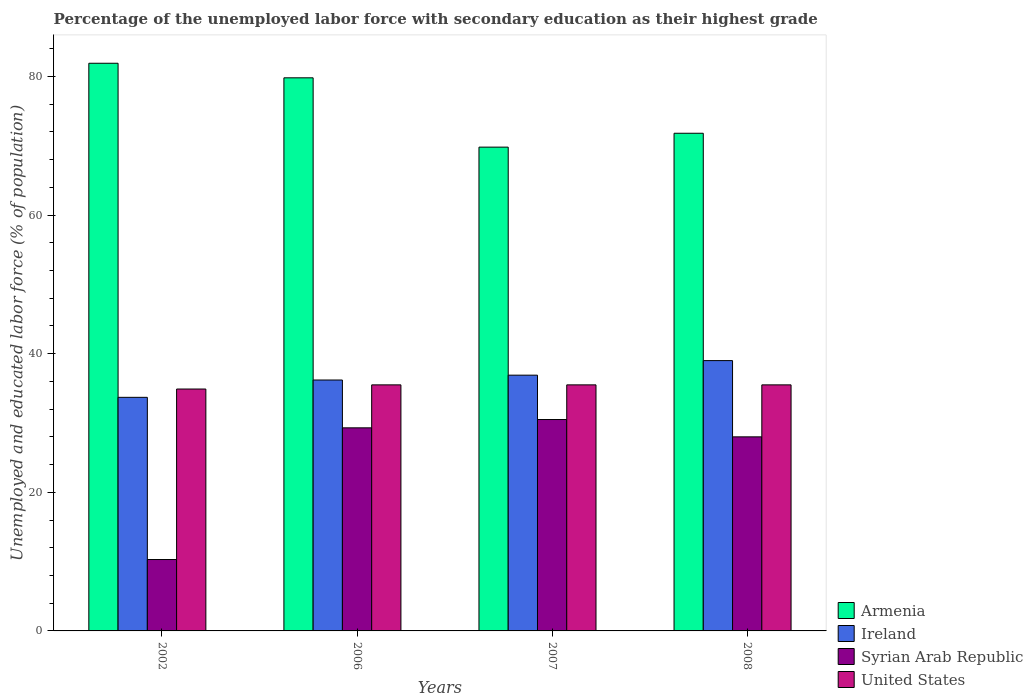How many different coloured bars are there?
Your answer should be very brief. 4. Are the number of bars per tick equal to the number of legend labels?
Keep it short and to the point. Yes. Are the number of bars on each tick of the X-axis equal?
Provide a short and direct response. Yes. How many bars are there on the 4th tick from the left?
Give a very brief answer. 4. How many bars are there on the 1st tick from the right?
Ensure brevity in your answer.  4. What is the label of the 2nd group of bars from the left?
Make the answer very short. 2006. What is the percentage of the unemployed labor force with secondary education in Armenia in 2002?
Your answer should be compact. 81.9. Across all years, what is the maximum percentage of the unemployed labor force with secondary education in Syrian Arab Republic?
Provide a succinct answer. 30.5. Across all years, what is the minimum percentage of the unemployed labor force with secondary education in Syrian Arab Republic?
Your response must be concise. 10.3. In which year was the percentage of the unemployed labor force with secondary education in Ireland maximum?
Offer a terse response. 2008. In which year was the percentage of the unemployed labor force with secondary education in Armenia minimum?
Give a very brief answer. 2007. What is the total percentage of the unemployed labor force with secondary education in Armenia in the graph?
Provide a short and direct response. 303.3. What is the difference between the percentage of the unemployed labor force with secondary education in Ireland in 2006 and that in 2007?
Offer a very short reply. -0.7. What is the difference between the percentage of the unemployed labor force with secondary education in United States in 2008 and the percentage of the unemployed labor force with secondary education in Ireland in 2007?
Keep it short and to the point. -1.4. What is the average percentage of the unemployed labor force with secondary education in Ireland per year?
Your answer should be very brief. 36.45. In the year 2006, what is the difference between the percentage of the unemployed labor force with secondary education in Armenia and percentage of the unemployed labor force with secondary education in United States?
Your answer should be very brief. 44.3. What is the ratio of the percentage of the unemployed labor force with secondary education in United States in 2002 to that in 2006?
Make the answer very short. 0.98. What is the difference between the highest and the second highest percentage of the unemployed labor force with secondary education in Syrian Arab Republic?
Make the answer very short. 1.2. What is the difference between the highest and the lowest percentage of the unemployed labor force with secondary education in Syrian Arab Republic?
Ensure brevity in your answer.  20.2. In how many years, is the percentage of the unemployed labor force with secondary education in Ireland greater than the average percentage of the unemployed labor force with secondary education in Ireland taken over all years?
Your answer should be very brief. 2. Is it the case that in every year, the sum of the percentage of the unemployed labor force with secondary education in Armenia and percentage of the unemployed labor force with secondary education in Syrian Arab Republic is greater than the sum of percentage of the unemployed labor force with secondary education in United States and percentage of the unemployed labor force with secondary education in Ireland?
Ensure brevity in your answer.  Yes. What does the 3rd bar from the left in 2007 represents?
Provide a short and direct response. Syrian Arab Republic. What does the 3rd bar from the right in 2002 represents?
Offer a very short reply. Ireland. Are all the bars in the graph horizontal?
Ensure brevity in your answer.  No. How many years are there in the graph?
Your answer should be compact. 4. What is the difference between two consecutive major ticks on the Y-axis?
Make the answer very short. 20. Are the values on the major ticks of Y-axis written in scientific E-notation?
Your answer should be very brief. No. Does the graph contain grids?
Offer a very short reply. No. Where does the legend appear in the graph?
Make the answer very short. Bottom right. What is the title of the graph?
Offer a terse response. Percentage of the unemployed labor force with secondary education as their highest grade. What is the label or title of the Y-axis?
Ensure brevity in your answer.  Unemployed and educated labor force (% of population). What is the Unemployed and educated labor force (% of population) in Armenia in 2002?
Provide a succinct answer. 81.9. What is the Unemployed and educated labor force (% of population) of Ireland in 2002?
Your answer should be very brief. 33.7. What is the Unemployed and educated labor force (% of population) of Syrian Arab Republic in 2002?
Provide a short and direct response. 10.3. What is the Unemployed and educated labor force (% of population) in United States in 2002?
Provide a succinct answer. 34.9. What is the Unemployed and educated labor force (% of population) of Armenia in 2006?
Your answer should be compact. 79.8. What is the Unemployed and educated labor force (% of population) of Ireland in 2006?
Provide a short and direct response. 36.2. What is the Unemployed and educated labor force (% of population) in Syrian Arab Republic in 2006?
Ensure brevity in your answer.  29.3. What is the Unemployed and educated labor force (% of population) of United States in 2006?
Ensure brevity in your answer.  35.5. What is the Unemployed and educated labor force (% of population) in Armenia in 2007?
Provide a succinct answer. 69.8. What is the Unemployed and educated labor force (% of population) of Ireland in 2007?
Offer a terse response. 36.9. What is the Unemployed and educated labor force (% of population) of Syrian Arab Republic in 2007?
Provide a short and direct response. 30.5. What is the Unemployed and educated labor force (% of population) of United States in 2007?
Make the answer very short. 35.5. What is the Unemployed and educated labor force (% of population) of Armenia in 2008?
Your response must be concise. 71.8. What is the Unemployed and educated labor force (% of population) of United States in 2008?
Ensure brevity in your answer.  35.5. Across all years, what is the maximum Unemployed and educated labor force (% of population) of Armenia?
Give a very brief answer. 81.9. Across all years, what is the maximum Unemployed and educated labor force (% of population) in Syrian Arab Republic?
Your answer should be very brief. 30.5. Across all years, what is the maximum Unemployed and educated labor force (% of population) of United States?
Provide a short and direct response. 35.5. Across all years, what is the minimum Unemployed and educated labor force (% of population) in Armenia?
Offer a very short reply. 69.8. Across all years, what is the minimum Unemployed and educated labor force (% of population) of Ireland?
Provide a succinct answer. 33.7. Across all years, what is the minimum Unemployed and educated labor force (% of population) in Syrian Arab Republic?
Your answer should be very brief. 10.3. Across all years, what is the minimum Unemployed and educated labor force (% of population) of United States?
Offer a very short reply. 34.9. What is the total Unemployed and educated labor force (% of population) of Armenia in the graph?
Offer a very short reply. 303.3. What is the total Unemployed and educated labor force (% of population) in Ireland in the graph?
Keep it short and to the point. 145.8. What is the total Unemployed and educated labor force (% of population) in Syrian Arab Republic in the graph?
Make the answer very short. 98.1. What is the total Unemployed and educated labor force (% of population) of United States in the graph?
Provide a succinct answer. 141.4. What is the difference between the Unemployed and educated labor force (% of population) of Syrian Arab Republic in 2002 and that in 2006?
Provide a succinct answer. -19. What is the difference between the Unemployed and educated labor force (% of population) in Ireland in 2002 and that in 2007?
Give a very brief answer. -3.2. What is the difference between the Unemployed and educated labor force (% of population) of Syrian Arab Republic in 2002 and that in 2007?
Your answer should be very brief. -20.2. What is the difference between the Unemployed and educated labor force (% of population) of United States in 2002 and that in 2007?
Offer a terse response. -0.6. What is the difference between the Unemployed and educated labor force (% of population) in Ireland in 2002 and that in 2008?
Provide a succinct answer. -5.3. What is the difference between the Unemployed and educated labor force (% of population) of Syrian Arab Republic in 2002 and that in 2008?
Your answer should be very brief. -17.7. What is the difference between the Unemployed and educated labor force (% of population) in United States in 2002 and that in 2008?
Make the answer very short. -0.6. What is the difference between the Unemployed and educated labor force (% of population) of United States in 2006 and that in 2007?
Make the answer very short. 0. What is the difference between the Unemployed and educated labor force (% of population) in Armenia in 2006 and that in 2008?
Provide a short and direct response. 8. What is the difference between the Unemployed and educated labor force (% of population) of Syrian Arab Republic in 2006 and that in 2008?
Your response must be concise. 1.3. What is the difference between the Unemployed and educated labor force (% of population) of United States in 2006 and that in 2008?
Give a very brief answer. 0. What is the difference between the Unemployed and educated labor force (% of population) in Ireland in 2007 and that in 2008?
Your answer should be very brief. -2.1. What is the difference between the Unemployed and educated labor force (% of population) of Syrian Arab Republic in 2007 and that in 2008?
Your answer should be compact. 2.5. What is the difference between the Unemployed and educated labor force (% of population) in United States in 2007 and that in 2008?
Make the answer very short. 0. What is the difference between the Unemployed and educated labor force (% of population) of Armenia in 2002 and the Unemployed and educated labor force (% of population) of Ireland in 2006?
Your answer should be very brief. 45.7. What is the difference between the Unemployed and educated labor force (% of population) of Armenia in 2002 and the Unemployed and educated labor force (% of population) of Syrian Arab Republic in 2006?
Your response must be concise. 52.6. What is the difference between the Unemployed and educated labor force (% of population) of Armenia in 2002 and the Unemployed and educated labor force (% of population) of United States in 2006?
Provide a short and direct response. 46.4. What is the difference between the Unemployed and educated labor force (% of population) of Ireland in 2002 and the Unemployed and educated labor force (% of population) of Syrian Arab Republic in 2006?
Give a very brief answer. 4.4. What is the difference between the Unemployed and educated labor force (% of population) in Syrian Arab Republic in 2002 and the Unemployed and educated labor force (% of population) in United States in 2006?
Your answer should be compact. -25.2. What is the difference between the Unemployed and educated labor force (% of population) in Armenia in 2002 and the Unemployed and educated labor force (% of population) in Ireland in 2007?
Offer a terse response. 45. What is the difference between the Unemployed and educated labor force (% of population) in Armenia in 2002 and the Unemployed and educated labor force (% of population) in Syrian Arab Republic in 2007?
Provide a short and direct response. 51.4. What is the difference between the Unemployed and educated labor force (% of population) in Armenia in 2002 and the Unemployed and educated labor force (% of population) in United States in 2007?
Keep it short and to the point. 46.4. What is the difference between the Unemployed and educated labor force (% of population) of Ireland in 2002 and the Unemployed and educated labor force (% of population) of United States in 2007?
Offer a very short reply. -1.8. What is the difference between the Unemployed and educated labor force (% of population) in Syrian Arab Republic in 2002 and the Unemployed and educated labor force (% of population) in United States in 2007?
Offer a terse response. -25.2. What is the difference between the Unemployed and educated labor force (% of population) in Armenia in 2002 and the Unemployed and educated labor force (% of population) in Ireland in 2008?
Give a very brief answer. 42.9. What is the difference between the Unemployed and educated labor force (% of population) of Armenia in 2002 and the Unemployed and educated labor force (% of population) of Syrian Arab Republic in 2008?
Your response must be concise. 53.9. What is the difference between the Unemployed and educated labor force (% of population) of Armenia in 2002 and the Unemployed and educated labor force (% of population) of United States in 2008?
Your answer should be very brief. 46.4. What is the difference between the Unemployed and educated labor force (% of population) of Ireland in 2002 and the Unemployed and educated labor force (% of population) of Syrian Arab Republic in 2008?
Your response must be concise. 5.7. What is the difference between the Unemployed and educated labor force (% of population) of Syrian Arab Republic in 2002 and the Unemployed and educated labor force (% of population) of United States in 2008?
Give a very brief answer. -25.2. What is the difference between the Unemployed and educated labor force (% of population) in Armenia in 2006 and the Unemployed and educated labor force (% of population) in Ireland in 2007?
Give a very brief answer. 42.9. What is the difference between the Unemployed and educated labor force (% of population) in Armenia in 2006 and the Unemployed and educated labor force (% of population) in Syrian Arab Republic in 2007?
Your answer should be compact. 49.3. What is the difference between the Unemployed and educated labor force (% of population) of Armenia in 2006 and the Unemployed and educated labor force (% of population) of United States in 2007?
Keep it short and to the point. 44.3. What is the difference between the Unemployed and educated labor force (% of population) in Ireland in 2006 and the Unemployed and educated labor force (% of population) in United States in 2007?
Offer a very short reply. 0.7. What is the difference between the Unemployed and educated labor force (% of population) in Armenia in 2006 and the Unemployed and educated labor force (% of population) in Ireland in 2008?
Give a very brief answer. 40.8. What is the difference between the Unemployed and educated labor force (% of population) of Armenia in 2006 and the Unemployed and educated labor force (% of population) of Syrian Arab Republic in 2008?
Your response must be concise. 51.8. What is the difference between the Unemployed and educated labor force (% of population) in Armenia in 2006 and the Unemployed and educated labor force (% of population) in United States in 2008?
Make the answer very short. 44.3. What is the difference between the Unemployed and educated labor force (% of population) of Ireland in 2006 and the Unemployed and educated labor force (% of population) of United States in 2008?
Make the answer very short. 0.7. What is the difference between the Unemployed and educated labor force (% of population) in Syrian Arab Republic in 2006 and the Unemployed and educated labor force (% of population) in United States in 2008?
Offer a terse response. -6.2. What is the difference between the Unemployed and educated labor force (% of population) in Armenia in 2007 and the Unemployed and educated labor force (% of population) in Ireland in 2008?
Provide a succinct answer. 30.8. What is the difference between the Unemployed and educated labor force (% of population) in Armenia in 2007 and the Unemployed and educated labor force (% of population) in Syrian Arab Republic in 2008?
Make the answer very short. 41.8. What is the difference between the Unemployed and educated labor force (% of population) of Armenia in 2007 and the Unemployed and educated labor force (% of population) of United States in 2008?
Offer a terse response. 34.3. What is the difference between the Unemployed and educated labor force (% of population) in Ireland in 2007 and the Unemployed and educated labor force (% of population) in Syrian Arab Republic in 2008?
Your response must be concise. 8.9. What is the difference between the Unemployed and educated labor force (% of population) in Syrian Arab Republic in 2007 and the Unemployed and educated labor force (% of population) in United States in 2008?
Offer a very short reply. -5. What is the average Unemployed and educated labor force (% of population) of Armenia per year?
Provide a short and direct response. 75.83. What is the average Unemployed and educated labor force (% of population) of Ireland per year?
Provide a short and direct response. 36.45. What is the average Unemployed and educated labor force (% of population) in Syrian Arab Republic per year?
Offer a terse response. 24.52. What is the average Unemployed and educated labor force (% of population) of United States per year?
Your answer should be compact. 35.35. In the year 2002, what is the difference between the Unemployed and educated labor force (% of population) of Armenia and Unemployed and educated labor force (% of population) of Ireland?
Your answer should be compact. 48.2. In the year 2002, what is the difference between the Unemployed and educated labor force (% of population) in Armenia and Unemployed and educated labor force (% of population) in Syrian Arab Republic?
Your answer should be very brief. 71.6. In the year 2002, what is the difference between the Unemployed and educated labor force (% of population) of Ireland and Unemployed and educated labor force (% of population) of Syrian Arab Republic?
Keep it short and to the point. 23.4. In the year 2002, what is the difference between the Unemployed and educated labor force (% of population) of Ireland and Unemployed and educated labor force (% of population) of United States?
Keep it short and to the point. -1.2. In the year 2002, what is the difference between the Unemployed and educated labor force (% of population) in Syrian Arab Republic and Unemployed and educated labor force (% of population) in United States?
Offer a very short reply. -24.6. In the year 2006, what is the difference between the Unemployed and educated labor force (% of population) in Armenia and Unemployed and educated labor force (% of population) in Ireland?
Keep it short and to the point. 43.6. In the year 2006, what is the difference between the Unemployed and educated labor force (% of population) in Armenia and Unemployed and educated labor force (% of population) in Syrian Arab Republic?
Keep it short and to the point. 50.5. In the year 2006, what is the difference between the Unemployed and educated labor force (% of population) of Armenia and Unemployed and educated labor force (% of population) of United States?
Your response must be concise. 44.3. In the year 2006, what is the difference between the Unemployed and educated labor force (% of population) of Ireland and Unemployed and educated labor force (% of population) of Syrian Arab Republic?
Your answer should be very brief. 6.9. In the year 2006, what is the difference between the Unemployed and educated labor force (% of population) in Ireland and Unemployed and educated labor force (% of population) in United States?
Provide a succinct answer. 0.7. In the year 2007, what is the difference between the Unemployed and educated labor force (% of population) in Armenia and Unemployed and educated labor force (% of population) in Ireland?
Your answer should be compact. 32.9. In the year 2007, what is the difference between the Unemployed and educated labor force (% of population) in Armenia and Unemployed and educated labor force (% of population) in Syrian Arab Republic?
Offer a very short reply. 39.3. In the year 2007, what is the difference between the Unemployed and educated labor force (% of population) in Armenia and Unemployed and educated labor force (% of population) in United States?
Provide a succinct answer. 34.3. In the year 2007, what is the difference between the Unemployed and educated labor force (% of population) of Ireland and Unemployed and educated labor force (% of population) of Syrian Arab Republic?
Provide a succinct answer. 6.4. In the year 2007, what is the difference between the Unemployed and educated labor force (% of population) of Ireland and Unemployed and educated labor force (% of population) of United States?
Keep it short and to the point. 1.4. In the year 2008, what is the difference between the Unemployed and educated labor force (% of population) of Armenia and Unemployed and educated labor force (% of population) of Ireland?
Offer a very short reply. 32.8. In the year 2008, what is the difference between the Unemployed and educated labor force (% of population) of Armenia and Unemployed and educated labor force (% of population) of Syrian Arab Republic?
Your answer should be very brief. 43.8. In the year 2008, what is the difference between the Unemployed and educated labor force (% of population) of Armenia and Unemployed and educated labor force (% of population) of United States?
Provide a short and direct response. 36.3. In the year 2008, what is the difference between the Unemployed and educated labor force (% of population) of Ireland and Unemployed and educated labor force (% of population) of United States?
Provide a succinct answer. 3.5. In the year 2008, what is the difference between the Unemployed and educated labor force (% of population) in Syrian Arab Republic and Unemployed and educated labor force (% of population) in United States?
Your answer should be compact. -7.5. What is the ratio of the Unemployed and educated labor force (% of population) of Armenia in 2002 to that in 2006?
Give a very brief answer. 1.03. What is the ratio of the Unemployed and educated labor force (% of population) in Ireland in 2002 to that in 2006?
Offer a very short reply. 0.93. What is the ratio of the Unemployed and educated labor force (% of population) of Syrian Arab Republic in 2002 to that in 2006?
Offer a terse response. 0.35. What is the ratio of the Unemployed and educated labor force (% of population) of United States in 2002 to that in 2006?
Offer a terse response. 0.98. What is the ratio of the Unemployed and educated labor force (% of population) of Armenia in 2002 to that in 2007?
Keep it short and to the point. 1.17. What is the ratio of the Unemployed and educated labor force (% of population) of Ireland in 2002 to that in 2007?
Offer a very short reply. 0.91. What is the ratio of the Unemployed and educated labor force (% of population) of Syrian Arab Republic in 2002 to that in 2007?
Offer a very short reply. 0.34. What is the ratio of the Unemployed and educated labor force (% of population) in United States in 2002 to that in 2007?
Your response must be concise. 0.98. What is the ratio of the Unemployed and educated labor force (% of population) of Armenia in 2002 to that in 2008?
Make the answer very short. 1.14. What is the ratio of the Unemployed and educated labor force (% of population) in Ireland in 2002 to that in 2008?
Offer a terse response. 0.86. What is the ratio of the Unemployed and educated labor force (% of population) in Syrian Arab Republic in 2002 to that in 2008?
Your response must be concise. 0.37. What is the ratio of the Unemployed and educated labor force (% of population) in United States in 2002 to that in 2008?
Offer a very short reply. 0.98. What is the ratio of the Unemployed and educated labor force (% of population) in Armenia in 2006 to that in 2007?
Make the answer very short. 1.14. What is the ratio of the Unemployed and educated labor force (% of population) in Syrian Arab Republic in 2006 to that in 2007?
Your response must be concise. 0.96. What is the ratio of the Unemployed and educated labor force (% of population) in United States in 2006 to that in 2007?
Give a very brief answer. 1. What is the ratio of the Unemployed and educated labor force (% of population) in Armenia in 2006 to that in 2008?
Provide a short and direct response. 1.11. What is the ratio of the Unemployed and educated labor force (% of population) in Ireland in 2006 to that in 2008?
Ensure brevity in your answer.  0.93. What is the ratio of the Unemployed and educated labor force (% of population) of Syrian Arab Republic in 2006 to that in 2008?
Give a very brief answer. 1.05. What is the ratio of the Unemployed and educated labor force (% of population) of Armenia in 2007 to that in 2008?
Keep it short and to the point. 0.97. What is the ratio of the Unemployed and educated labor force (% of population) in Ireland in 2007 to that in 2008?
Provide a succinct answer. 0.95. What is the ratio of the Unemployed and educated labor force (% of population) in Syrian Arab Republic in 2007 to that in 2008?
Your answer should be very brief. 1.09. What is the ratio of the Unemployed and educated labor force (% of population) in United States in 2007 to that in 2008?
Your answer should be compact. 1. What is the difference between the highest and the second highest Unemployed and educated labor force (% of population) in Syrian Arab Republic?
Your answer should be very brief. 1.2. What is the difference between the highest and the second highest Unemployed and educated labor force (% of population) in United States?
Ensure brevity in your answer.  0. What is the difference between the highest and the lowest Unemployed and educated labor force (% of population) in Ireland?
Give a very brief answer. 5.3. What is the difference between the highest and the lowest Unemployed and educated labor force (% of population) of Syrian Arab Republic?
Your response must be concise. 20.2. What is the difference between the highest and the lowest Unemployed and educated labor force (% of population) of United States?
Your answer should be compact. 0.6. 